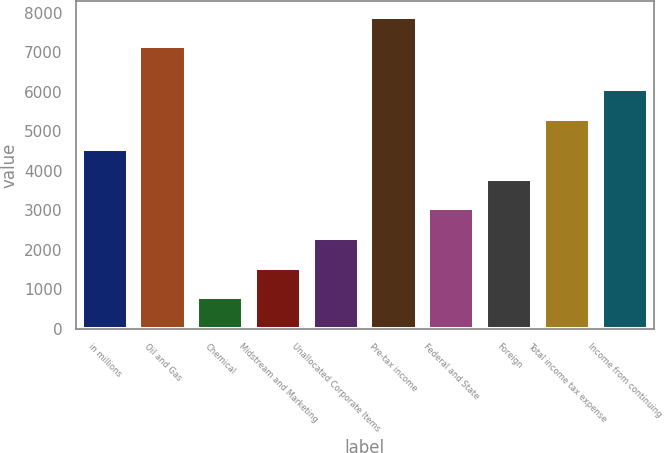Convert chart. <chart><loc_0><loc_0><loc_500><loc_500><bar_chart><fcel>in millions<fcel>Oil and Gas<fcel>Chemical<fcel>Midstream and Marketing<fcel>Unallocated Corporate Items<fcel>Pre-tax income<fcel>Federal and State<fcel>Foreign<fcel>Total income tax expense<fcel>Income from continuing<nl><fcel>4554.4<fcel>7151<fcel>792.4<fcel>1544.8<fcel>2297.2<fcel>7903.4<fcel>3049.6<fcel>3802<fcel>5306.8<fcel>6059.2<nl></chart> 